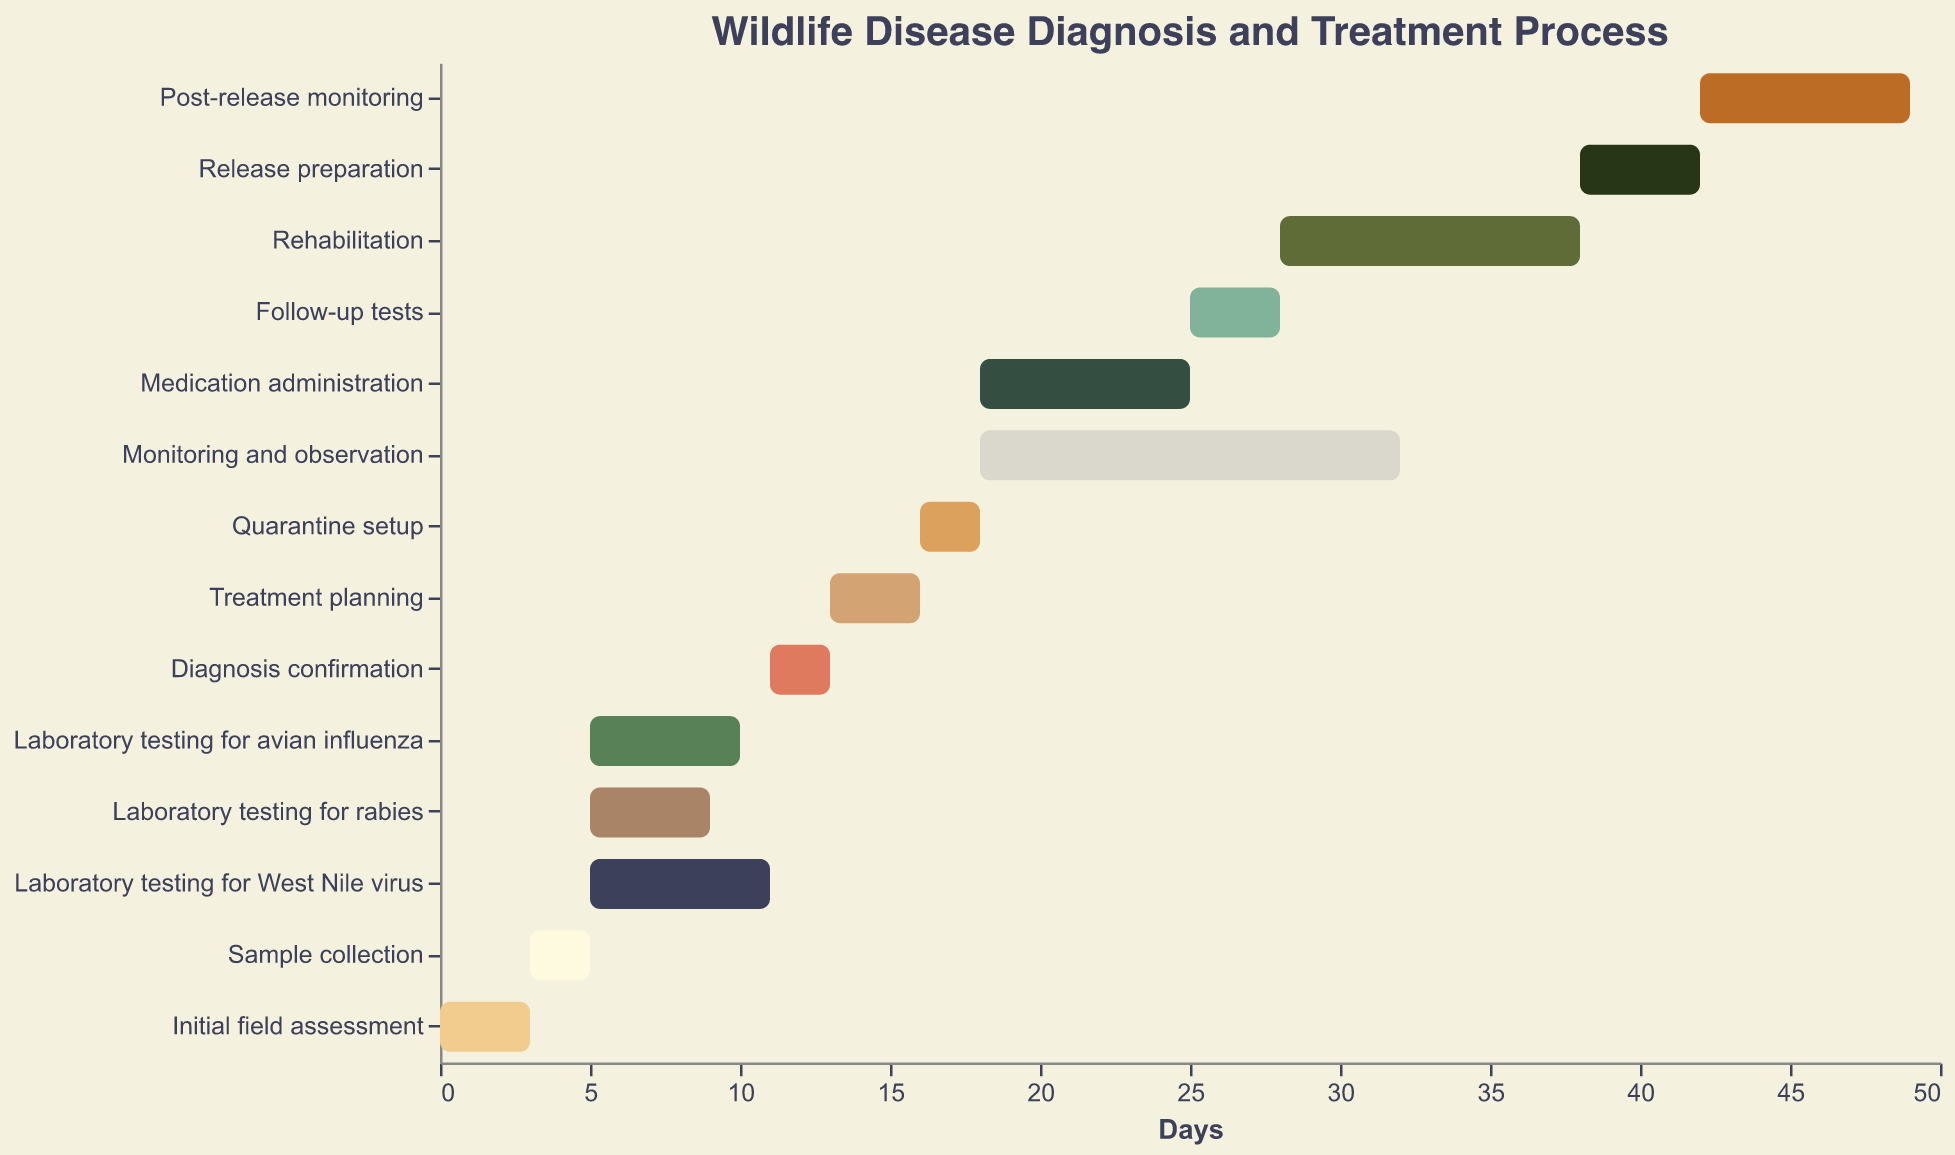What's the total duration of the initial field assessment and sample collection combined? The initial field assessment lasts for 3 days and the sample collection takes 2 days. Adding these together gives the total duration.
Answer: 5 days How many different tasks start on Day 5? On Day 5, there are three tasks starting: Laboratory testing for avian influenza, Laboratory testing for rabies, and Laboratory testing for West Nile virus.
Answer: 3 tasks Which task has the longest duration? By looking at the duration column, Monitoring and observation has the longest duration of 14 days.
Answer: Monitoring and observation What is the duration difference between the longest and shortest task? Monitoring and observation is the longest task with 14 days, and Quarantine setup is the shortest with 2 days. The difference is 14 - 2 = 12 days.
Answer: 12 days Which tasks have overlapping durations? Tasks starting on the same day and continuing over multiple days overlap. Laboratory testing for avian influenza, Laboratory testing for rabies, and Laboratory testing for West Nile virus (starting on Day 5), and Medication administration and Monitoring and observation (starting on Day 18) overlap.
Answer: Multiple pairs What are the start and end days for the Rehabilitation process? The start day for Rehabilitation is 28 and the duration is 10 days, so it ends on day 28 + 10 = 38.
Answer: Starts on Day 28, ends on Day 38 Compare the durations of Laboratory testing for avian influenza and Laboratory testing for West Nile virus. Which is longer? Laboratory testing for avian influenza lasts for 5 days, while Laboratory testing for West Nile virus lasts for 6 days. West Nile virus testing is longer.
Answer: West Nile virus testing How long is the entire diagnosis and treatment process from start to the end of post-release monitoring? The initial field assessment starts on Day 0 and Post-release monitoring ends on Day 49. So, the whole process takes 50 days.
Answer: 50 days Identify the tasks that follow immediately after Laboratory testing for rabies. Diagnosis confirmation follows immediately after Laboratory testing for rabies as it starts on Day 11, when rabies testing, which starts on Day 5 and lasts for 4 days, ends.
Answer: Diagnosis confirmation 